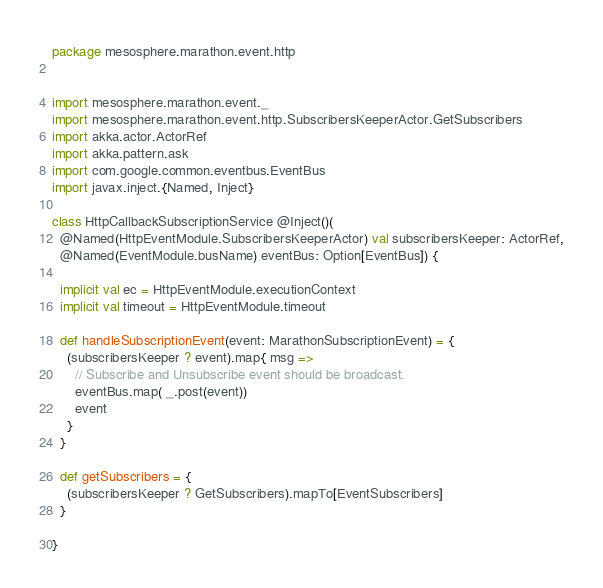<code> <loc_0><loc_0><loc_500><loc_500><_Scala_>package mesosphere.marathon.event.http


import mesosphere.marathon.event._
import mesosphere.marathon.event.http.SubscribersKeeperActor.GetSubscribers
import akka.actor.ActorRef
import akka.pattern.ask
import com.google.common.eventbus.EventBus
import javax.inject.{Named, Inject}

class HttpCallbackSubscriptionService @Inject()(
  @Named(HttpEventModule.SubscribersKeeperActor) val subscribersKeeper: ActorRef,
  @Named(EventModule.busName) eventBus: Option[EventBus]) {

  implicit val ec = HttpEventModule.executionContext
  implicit val timeout = HttpEventModule.timeout

  def handleSubscriptionEvent(event: MarathonSubscriptionEvent) = {
    (subscribersKeeper ? event).map{ msg =>
      // Subscribe and Unsubscribe event should be broadcast.
      eventBus.map( _.post(event))
      event
    }
  }

  def getSubscribers = {
    (subscribersKeeper ? GetSubscribers).mapTo[EventSubscribers]
  }

}
</code> 